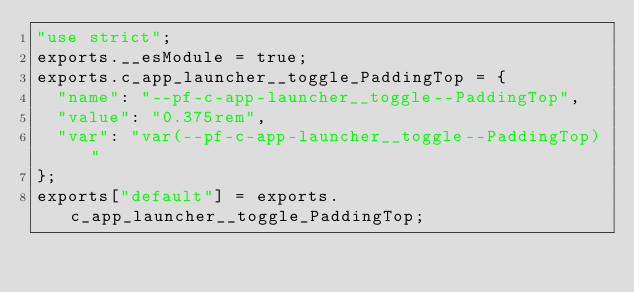<code> <loc_0><loc_0><loc_500><loc_500><_JavaScript_>"use strict";
exports.__esModule = true;
exports.c_app_launcher__toggle_PaddingTop = {
  "name": "--pf-c-app-launcher__toggle--PaddingTop",
  "value": "0.375rem",
  "var": "var(--pf-c-app-launcher__toggle--PaddingTop)"
};
exports["default"] = exports.c_app_launcher__toggle_PaddingTop;</code> 